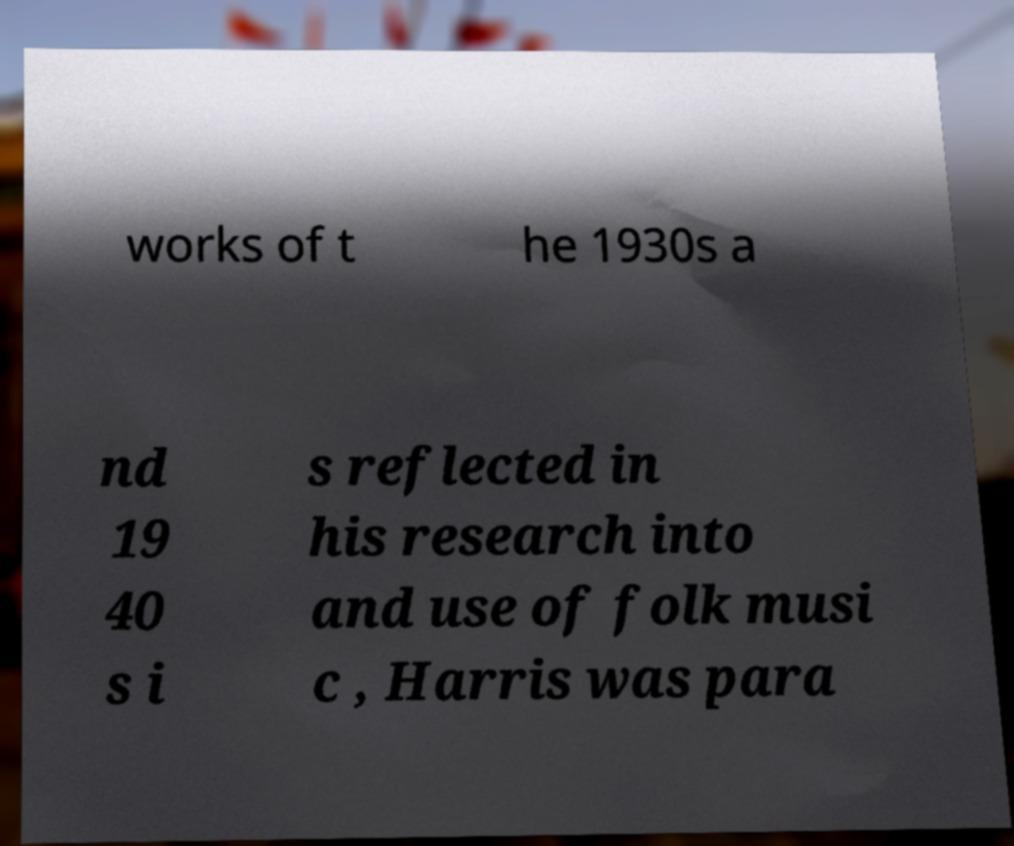I need the written content from this picture converted into text. Can you do that? works of t he 1930s a nd 19 40 s i s reflected in his research into and use of folk musi c , Harris was para 